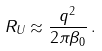Convert formula to latex. <formula><loc_0><loc_0><loc_500><loc_500>R _ { U } \approx \frac { q ^ { 2 } } { 2 \pi \beta _ { 0 } } \, .</formula> 